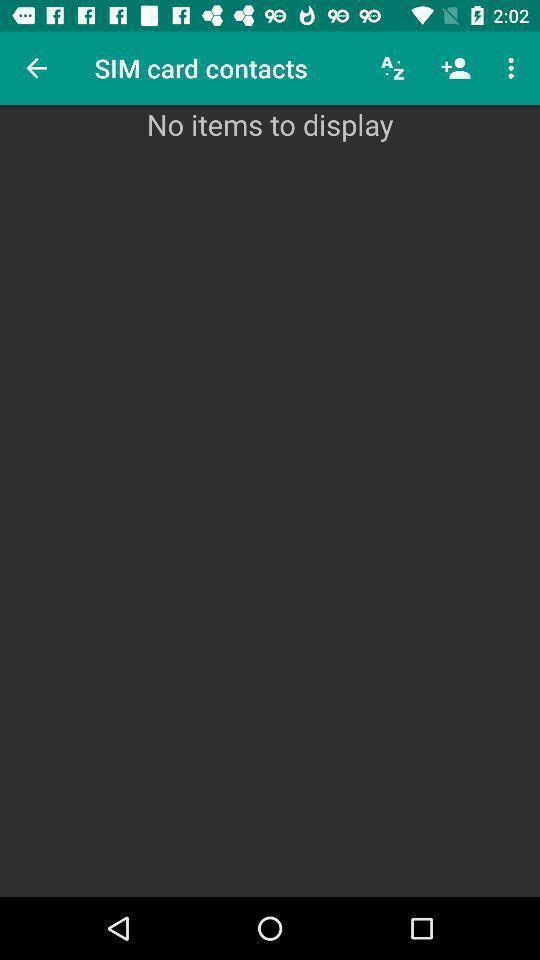Summarize the main components in this picture. Page showing different contact details present in application. 